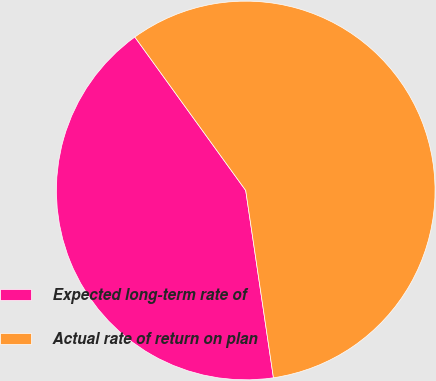Convert chart to OTSL. <chart><loc_0><loc_0><loc_500><loc_500><pie_chart><fcel>Expected long-term rate of<fcel>Actual rate of return on plan<nl><fcel>42.38%<fcel>57.62%<nl></chart> 